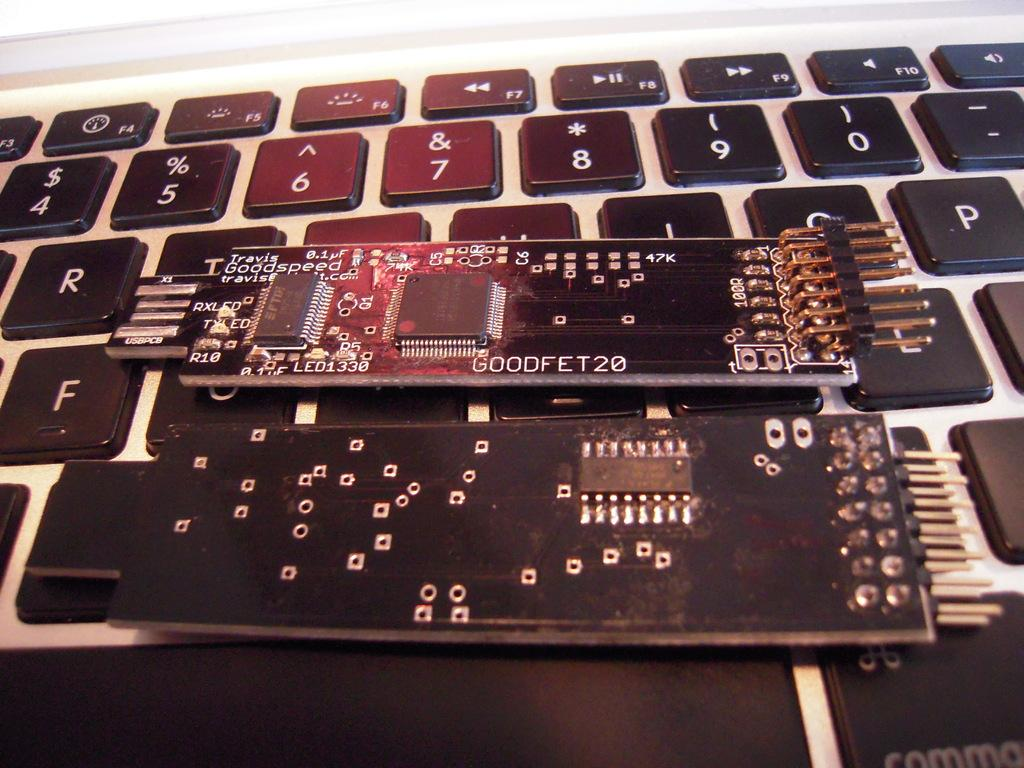What is the main object in the image? There is a keyboard in the image. What can be seen on the buttons of the keyboard? The buttons on the keyboard have numbers and symbols. Are there any additional objects on the keyboard? Yes, there are two devices on the keyboard. What type of land can be seen in the background of the image? There is no land visible in the image, as it focuses on the keyboard and its buttons. 